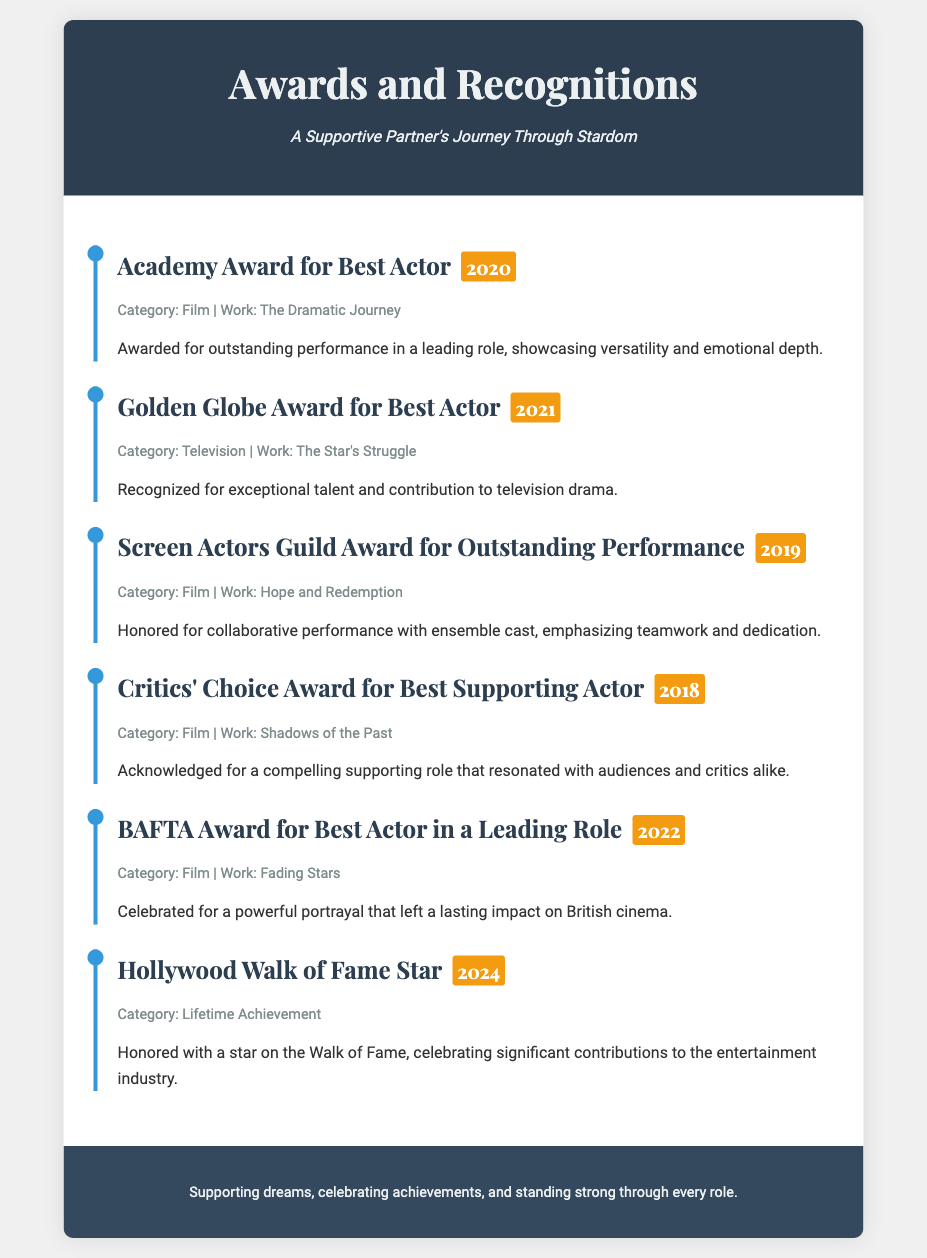What is the title of the award received in 2020? The 2020 award title mentioned is the Academy Award for Best Actor.
Answer: Academy Award for Best Actor Which work was recognized by the Golden Globe Award in 2021? The work recognized by the Golden Globe Award in 2021 is "The Star's Struggle."
Answer: The Star's Struggle How many awards are listed in total? There are six awards listed in the document.
Answer: 6 What category does the Hollywood Walk of Fame Star fall under? The Hollywood Walk of Fame Star is categorized under Lifetime Achievement.
Answer: Lifetime Achievement Which award was received for the work "Shadows of the Past"? The Critics' Choice Award for Best Supporting Actor was received for "Shadows of the Past."
Answer: Critics' Choice Award for Best Supporting Actor What is a common theme highlighted in the award descriptions? Common themes include outstanding performance and contributions to the entertainment industry.
Answer: Outstanding performance Who received the BAFTA Award for Best Actor in a Leading Role in 2022? The document does not specify the name of the recipient for the BAFTA Award in 2022.
Answer: Not specified In what year will the Hollywood Walk of Fame Star be awarded? The Hollywood Walk of Fame Star is scheduled to be awarded in 2024.
Answer: 2024 